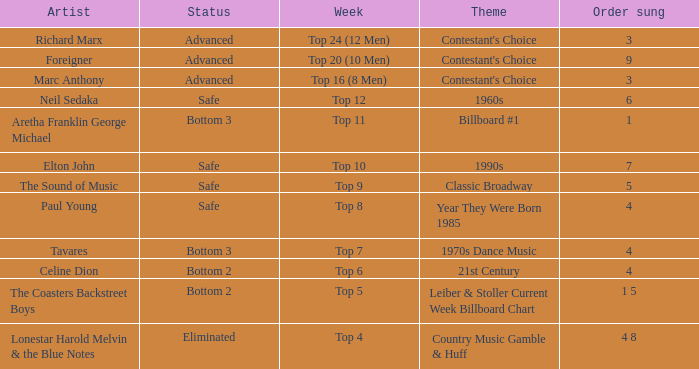What artist's song was performed in the week with theme of Billboard #1? Aretha Franklin George Michael. 